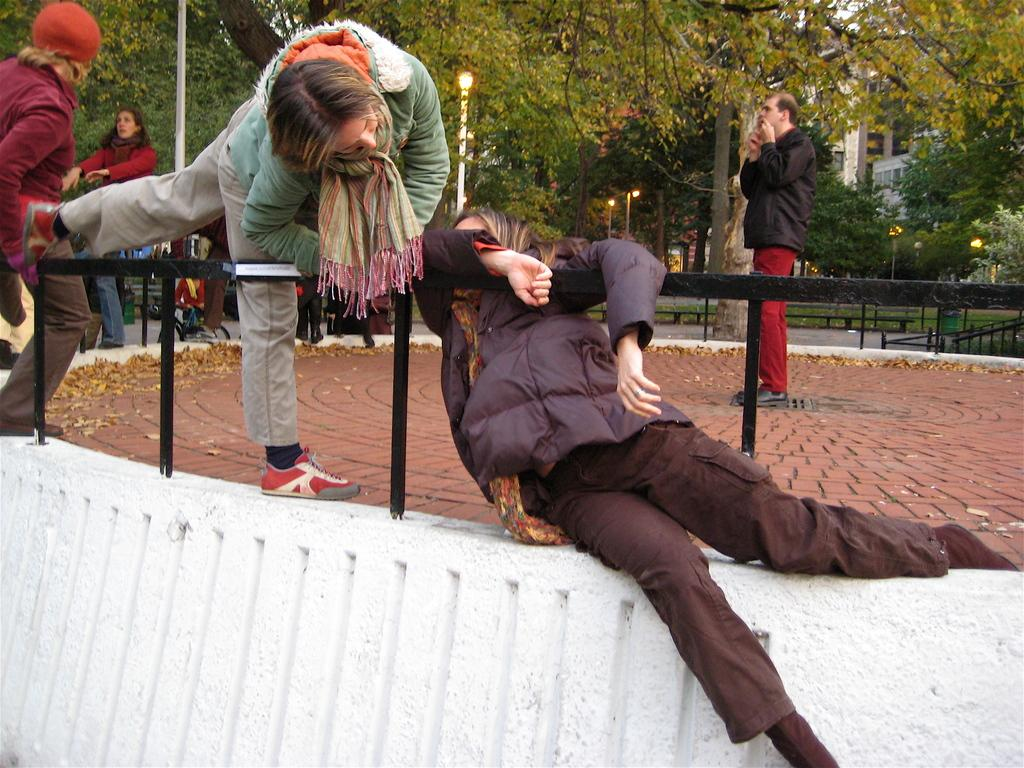What are the two persons on the left side of the image doing? The two persons on the left side of the image are holding a fence. Where are the two persons located? They are on a white wall. What can be seen in the background of the image? There are other persons, trees, and a building in the background of the image. What type of twig is being used as a unit of measurement by the persons in the image? There is no twig present in the image, and no unit of measurement is being used by the persons. 